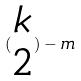<formula> <loc_0><loc_0><loc_500><loc_500>( \begin{matrix} k \\ 2 \end{matrix} ) - m</formula> 